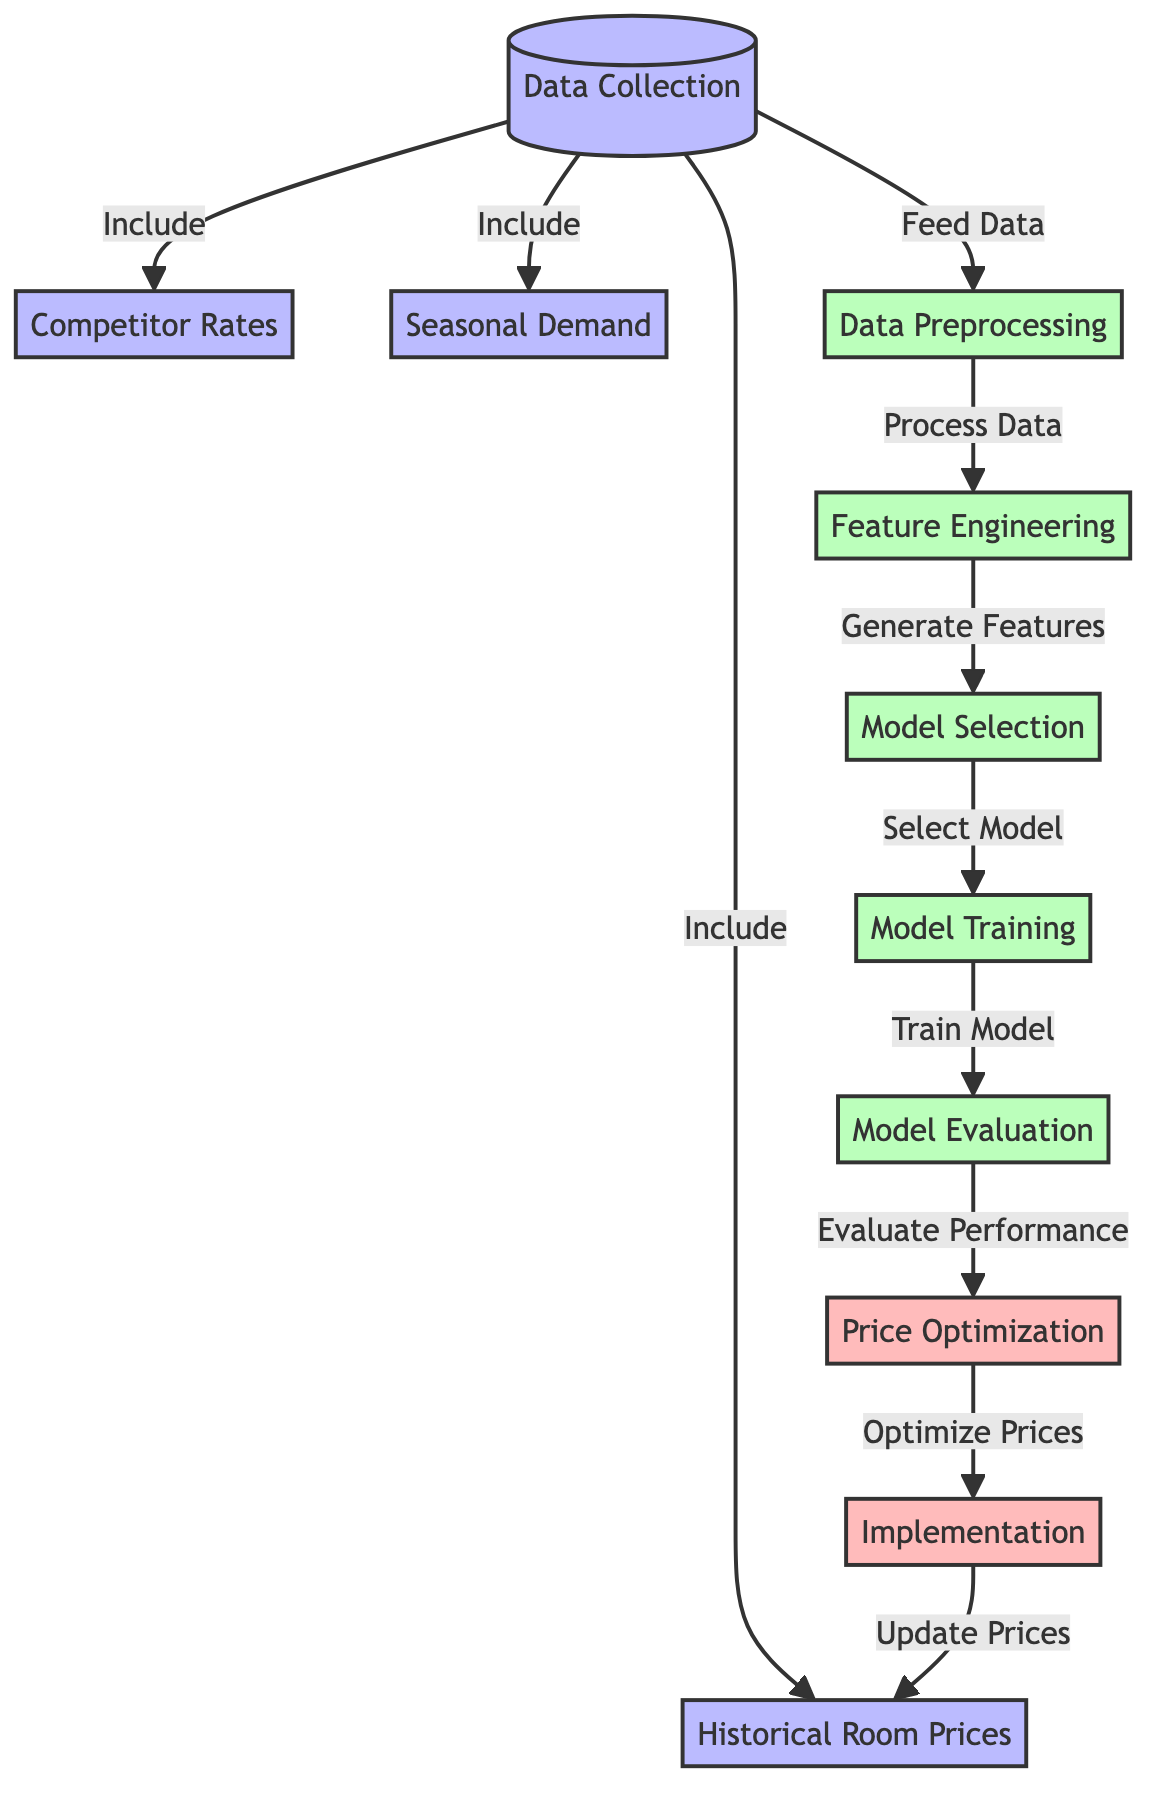What is the first step in the process? The first step in the process is "Data Collection", which is indicated at the top of the diagram. This step includes gathering the necessary data needed for analysis.
Answer: Data Collection How many main data sources are identified in the diagram? The diagram identifies three main data sources: "Competitor Rates", "Seasonal Demand", and "Historical Room Prices". These sources feed into the Data Preprocessing step.
Answer: Three What is the last step before price optimization? The last step before price optimization is "Model Evaluation". This step assesses the performance of the trained model prior to optimizing prices.
Answer: Model Evaluation Which component processes the collected data? The component that processes the collected data is "Data Preprocessing". It follows the data collection step and is responsible for cleaning and preparing the data for feature engineering.
Answer: Data Preprocessing What relationship is shown between model training and evaluation? The diagram shows a directed flow from "Model Training" to "Model Evaluation", indicating that the model is trained first and then evaluated to measure its performance.
Answer: Model Training to Model Evaluation Which output is generated from the price optimization step? The output generated from the price optimization step is "Implementation". This step involves applying the optimized prices based on the evaluation of the model.
Answer: Implementation What type of features are generated in the feature engineering step? The feature engineering step generates relevant features needed for the model selection process, drawing from the processed data.
Answer: Generate Features Which step updates the historical room prices? The step that updates the historical room prices is "Implementation". It takes the optimized prices and applies them to the existing pricing strategy.
Answer: Implementation What precedes the model selection step in the diagram? The step that precedes the model selection is "Feature Engineering", which creates the necessary data features for the model to be selected.
Answer: Feature Engineering 